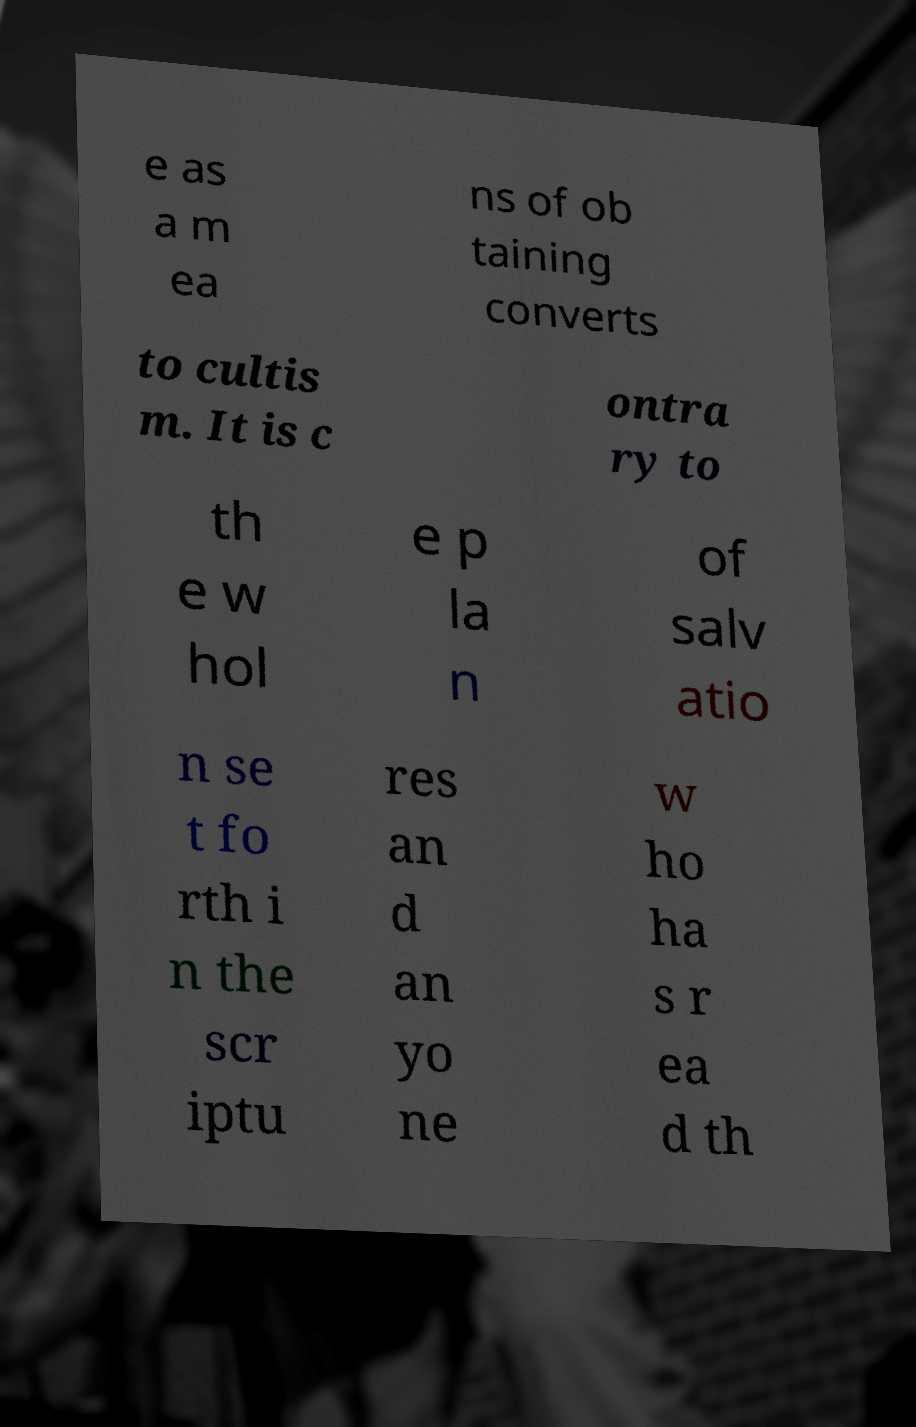Can you accurately transcribe the text from the provided image for me? e as a m ea ns of ob taining converts to cultis m. It is c ontra ry to th e w hol e p la n of salv atio n se t fo rth i n the scr iptu res an d an yo ne w ho ha s r ea d th 